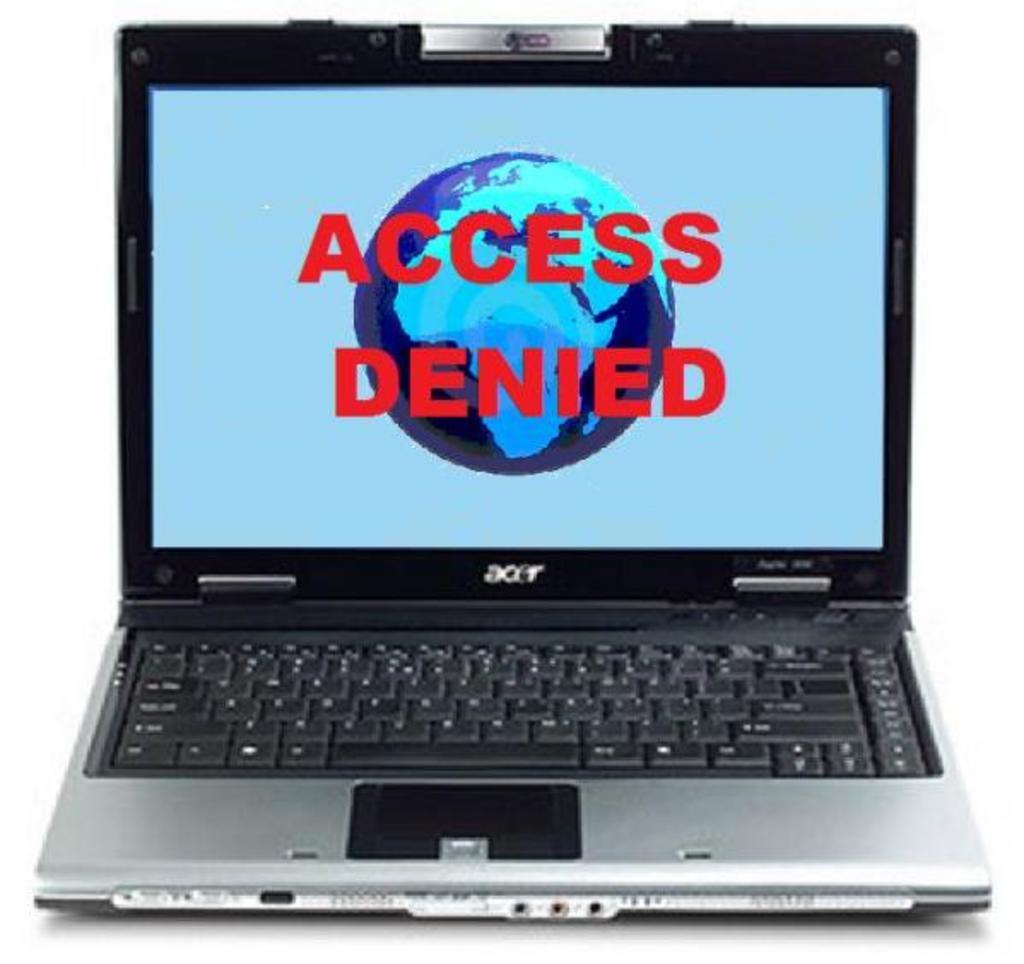Was access denied or granted?
Offer a terse response. Denied. Was access denied?
Offer a terse response. Yes. 